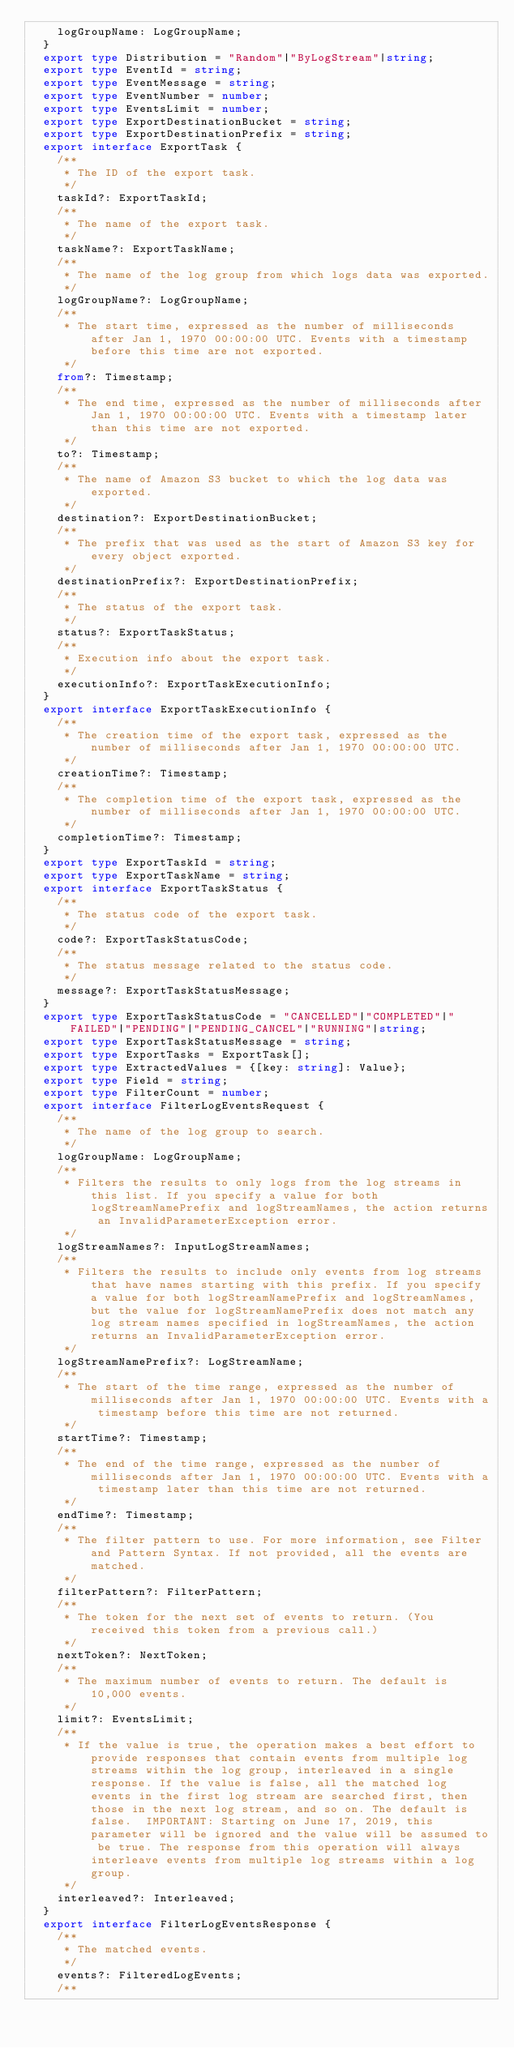Convert code to text. <code><loc_0><loc_0><loc_500><loc_500><_TypeScript_>    logGroupName: LogGroupName;
  }
  export type Distribution = "Random"|"ByLogStream"|string;
  export type EventId = string;
  export type EventMessage = string;
  export type EventNumber = number;
  export type EventsLimit = number;
  export type ExportDestinationBucket = string;
  export type ExportDestinationPrefix = string;
  export interface ExportTask {
    /**
     * The ID of the export task.
     */
    taskId?: ExportTaskId;
    /**
     * The name of the export task.
     */
    taskName?: ExportTaskName;
    /**
     * The name of the log group from which logs data was exported.
     */
    logGroupName?: LogGroupName;
    /**
     * The start time, expressed as the number of milliseconds after Jan 1, 1970 00:00:00 UTC. Events with a timestamp before this time are not exported.
     */
    from?: Timestamp;
    /**
     * The end time, expressed as the number of milliseconds after Jan 1, 1970 00:00:00 UTC. Events with a timestamp later than this time are not exported.
     */
    to?: Timestamp;
    /**
     * The name of Amazon S3 bucket to which the log data was exported.
     */
    destination?: ExportDestinationBucket;
    /**
     * The prefix that was used as the start of Amazon S3 key for every object exported.
     */
    destinationPrefix?: ExportDestinationPrefix;
    /**
     * The status of the export task.
     */
    status?: ExportTaskStatus;
    /**
     * Execution info about the export task.
     */
    executionInfo?: ExportTaskExecutionInfo;
  }
  export interface ExportTaskExecutionInfo {
    /**
     * The creation time of the export task, expressed as the number of milliseconds after Jan 1, 1970 00:00:00 UTC.
     */
    creationTime?: Timestamp;
    /**
     * The completion time of the export task, expressed as the number of milliseconds after Jan 1, 1970 00:00:00 UTC.
     */
    completionTime?: Timestamp;
  }
  export type ExportTaskId = string;
  export type ExportTaskName = string;
  export interface ExportTaskStatus {
    /**
     * The status code of the export task.
     */
    code?: ExportTaskStatusCode;
    /**
     * The status message related to the status code.
     */
    message?: ExportTaskStatusMessage;
  }
  export type ExportTaskStatusCode = "CANCELLED"|"COMPLETED"|"FAILED"|"PENDING"|"PENDING_CANCEL"|"RUNNING"|string;
  export type ExportTaskStatusMessage = string;
  export type ExportTasks = ExportTask[];
  export type ExtractedValues = {[key: string]: Value};
  export type Field = string;
  export type FilterCount = number;
  export interface FilterLogEventsRequest {
    /**
     * The name of the log group to search.
     */
    logGroupName: LogGroupName;
    /**
     * Filters the results to only logs from the log streams in this list. If you specify a value for both logStreamNamePrefix and logStreamNames, the action returns an InvalidParameterException error.
     */
    logStreamNames?: InputLogStreamNames;
    /**
     * Filters the results to include only events from log streams that have names starting with this prefix. If you specify a value for both logStreamNamePrefix and logStreamNames, but the value for logStreamNamePrefix does not match any log stream names specified in logStreamNames, the action returns an InvalidParameterException error.
     */
    logStreamNamePrefix?: LogStreamName;
    /**
     * The start of the time range, expressed as the number of milliseconds after Jan 1, 1970 00:00:00 UTC. Events with a timestamp before this time are not returned.
     */
    startTime?: Timestamp;
    /**
     * The end of the time range, expressed as the number of milliseconds after Jan 1, 1970 00:00:00 UTC. Events with a timestamp later than this time are not returned.
     */
    endTime?: Timestamp;
    /**
     * The filter pattern to use. For more information, see Filter and Pattern Syntax. If not provided, all the events are matched.
     */
    filterPattern?: FilterPattern;
    /**
     * The token for the next set of events to return. (You received this token from a previous call.)
     */
    nextToken?: NextToken;
    /**
     * The maximum number of events to return. The default is 10,000 events.
     */
    limit?: EventsLimit;
    /**
     * If the value is true, the operation makes a best effort to provide responses that contain events from multiple log streams within the log group, interleaved in a single response. If the value is false, all the matched log events in the first log stream are searched first, then those in the next log stream, and so on. The default is false.  IMPORTANT: Starting on June 17, 2019, this parameter will be ignored and the value will be assumed to be true. The response from this operation will always interleave events from multiple log streams within a log group.
     */
    interleaved?: Interleaved;
  }
  export interface FilterLogEventsResponse {
    /**
     * The matched events.
     */
    events?: FilteredLogEvents;
    /**</code> 